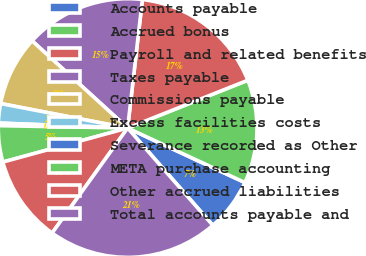Convert chart to OTSL. <chart><loc_0><loc_0><loc_500><loc_500><pie_chart><fcel>Accounts payable<fcel>Accrued bonus<fcel>Payroll and related benefits<fcel>Taxes payable<fcel>Commissions payable<fcel>Excess facilities costs<fcel>Severance recorded as Other<fcel>META purchase accounting<fcel>Other accrued liabilities<fcel>Total accounts payable and<nl><fcel>6.63%<fcel>12.95%<fcel>17.16%<fcel>15.05%<fcel>8.74%<fcel>2.42%<fcel>0.32%<fcel>4.53%<fcel>10.84%<fcel>21.37%<nl></chart> 